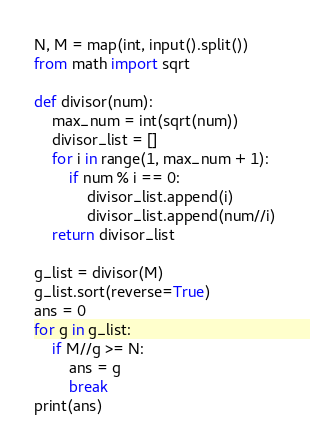<code> <loc_0><loc_0><loc_500><loc_500><_Python_>N, M = map(int, input().split())
from math import sqrt

def divisor(num):
    max_num = int(sqrt(num))
    divisor_list = []
    for i in range(1, max_num + 1):
        if num % i == 0:
            divisor_list.append(i)
            divisor_list.append(num//i)
    return divisor_list

g_list = divisor(M)
g_list.sort(reverse=True)
ans = 0
for g in g_list:
    if M//g >= N:
        ans = g
        break
print(ans)</code> 